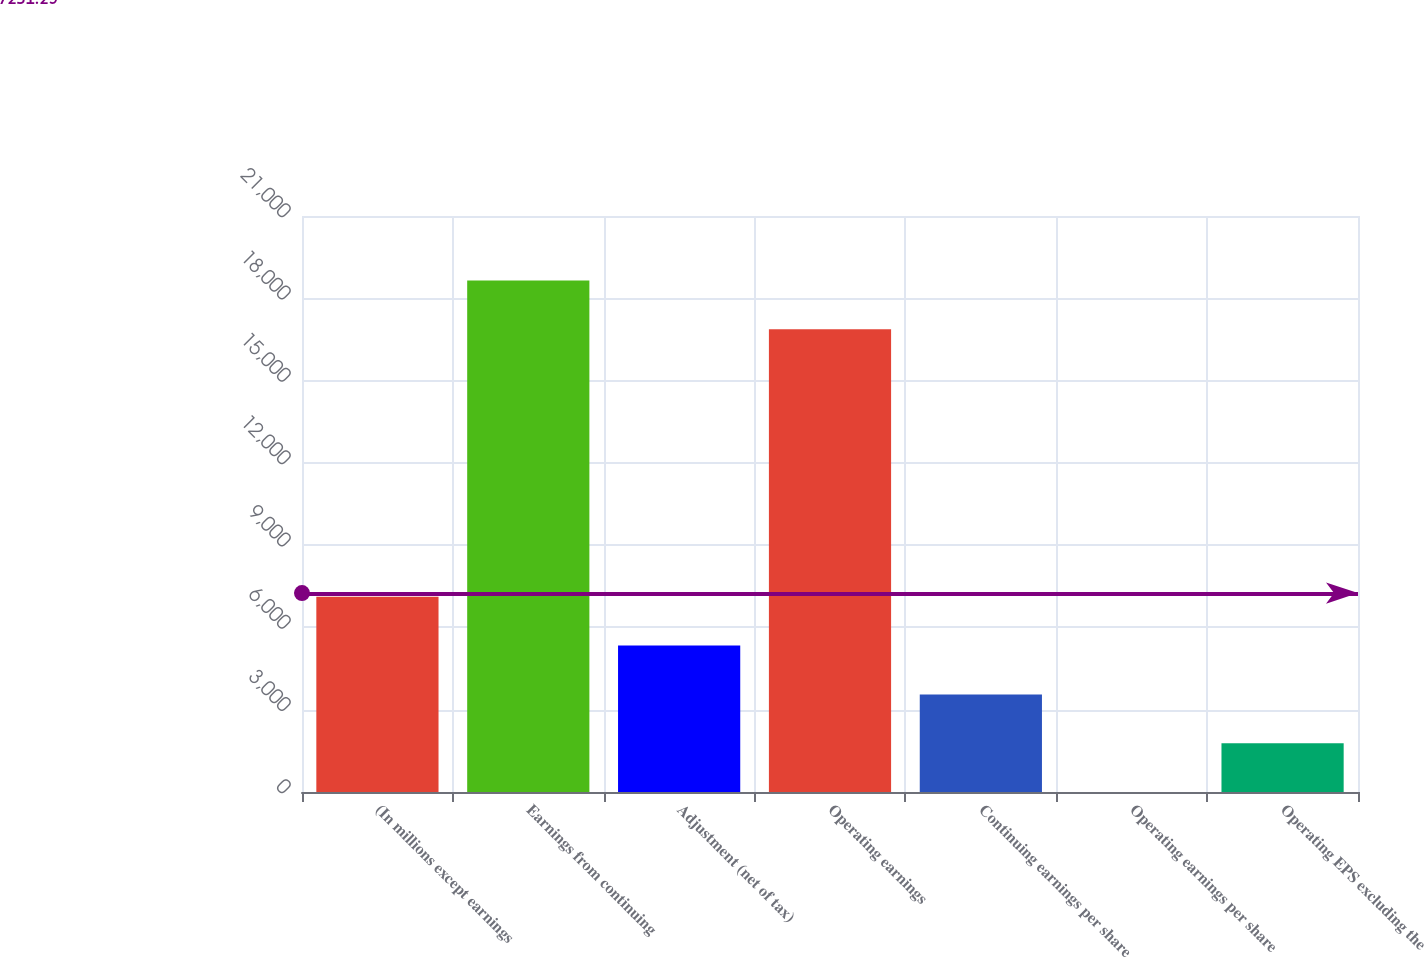Convert chart to OTSL. <chart><loc_0><loc_0><loc_500><loc_500><bar_chart><fcel>(In millions except earnings<fcel>Earnings from continuing<fcel>Adjustment (net of tax)<fcel>Operating earnings<fcel>Continuing earnings per share<fcel>Operating earnings per share<fcel>Operating EPS excluding the<nl><fcel>7115.38<fcel>18649.4<fcel>5336.95<fcel>16871<fcel>3558.52<fcel>1.66<fcel>1780.09<nl></chart> 